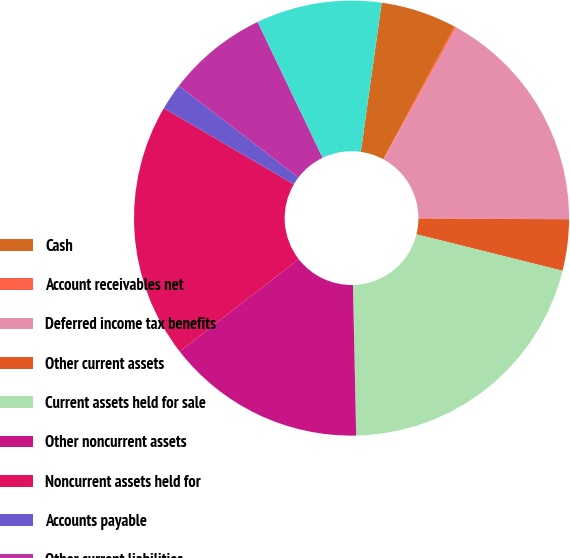Convert chart to OTSL. <chart><loc_0><loc_0><loc_500><loc_500><pie_chart><fcel>Cash<fcel>Account receivables net<fcel>Deferred income tax benefits<fcel>Other current assets<fcel>Current assets held for sale<fcel>Other noncurrent assets<fcel>Noncurrent assets held for<fcel>Accounts payable<fcel>Other current liabilities<fcel>Current liabilities held for<nl><fcel>5.65%<fcel>0.13%<fcel>17.09%<fcel>3.81%<fcel>20.77%<fcel>14.84%<fcel>18.93%<fcel>1.97%<fcel>7.49%<fcel>9.32%<nl></chart> 